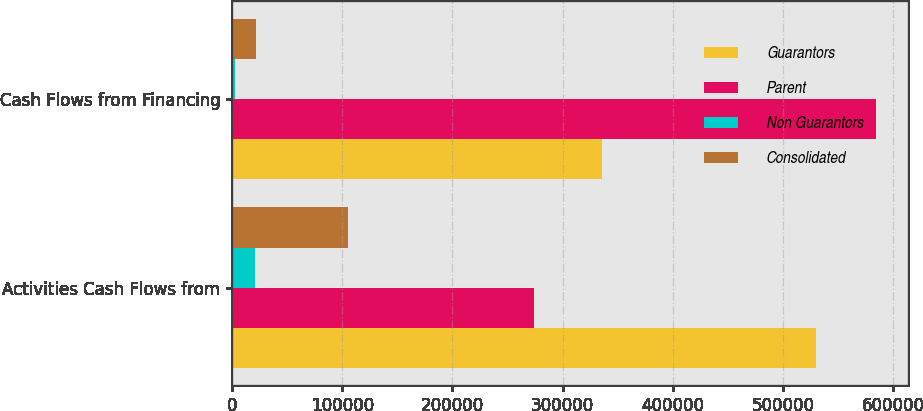Convert chart to OTSL. <chart><loc_0><loc_0><loc_500><loc_500><stacked_bar_chart><ecel><fcel>Activities Cash Flows from<fcel>Cash Flows from Financing<nl><fcel>Guarantors<fcel>530160<fcel>335663<nl><fcel>Parent<fcel>274003<fcel>584507<nl><fcel>Non Guarantors<fcel>20799<fcel>2382<nl><fcel>Consolidated<fcel>105221<fcel>21489<nl></chart> 